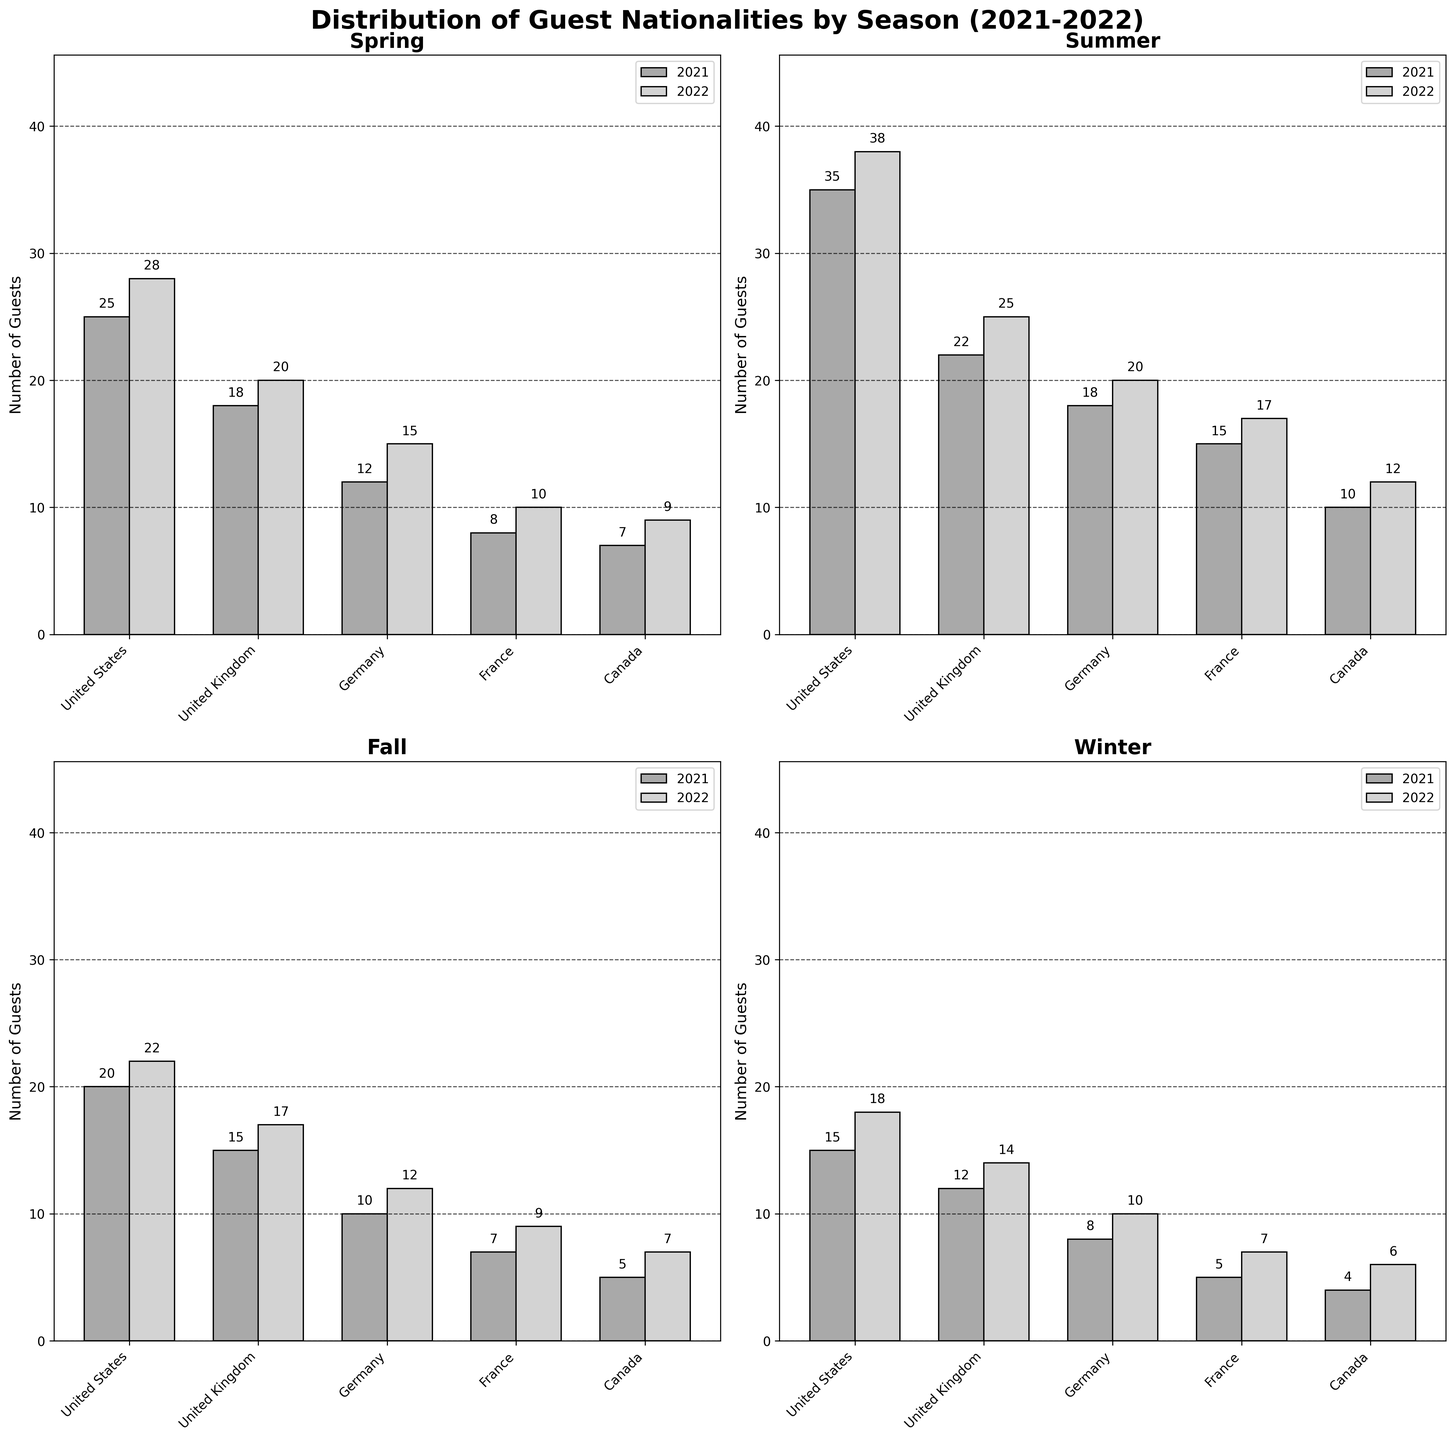What is the highest number of guests from the United States in any season? The highest number of guests from the United States shown in the bars is 38, which is found in the Summer 2022 subplot.
Answer: 38 How many guests from Germany visited in Fall 2021? In the Fall 2021 subplot, the bar for Germany shows a height corresponding to 10 guests.
Answer: 10 Which season had the most significant increase in the number of guests from Canada between 2021 and 2022? By looking at the bars for Canada across all seasons, the difference between 2021 and 2022 is largest in Summer, increasing from 10 to 12, a difference of 2 guests.
Answer: Summer Which nationality had the smallest number of guests in Winter 2022? The Winter 2022 subplot shows Canada with the smallest bar height, representing 6 guests.
Answer: Canada What is the total number of guests from the United Kingdom in Spring 2021 and 2022 combined? In Spring 2021, there were 18 guests from the UK, and in Spring 2022, there were 20. Adding these up gives 38 guests in total.
Answer: 38 In which season did France see the biggest year-over-year growth in guest numbers from 2021 to 2022? Evaluating the increments for each season, Summer had the biggest increase for France, going from 15 in 2021 to 17 in 2022, a growth of 2 guests.
Answer: Summer How many bars in total are there across all subplots? Each subplot has 10 bars (5 nationalities for 2 years), and there are 4 subplots, resulting in 40 bars in total.
Answer: 40 Which nationality showed the most consistent guest numbers across all seasons from 2021 to 2022? By assessing the bar distances visually, Canada's numbers had the least variability across all seasons, with increments always of 1 to 2 guests.
Answer: Canada 